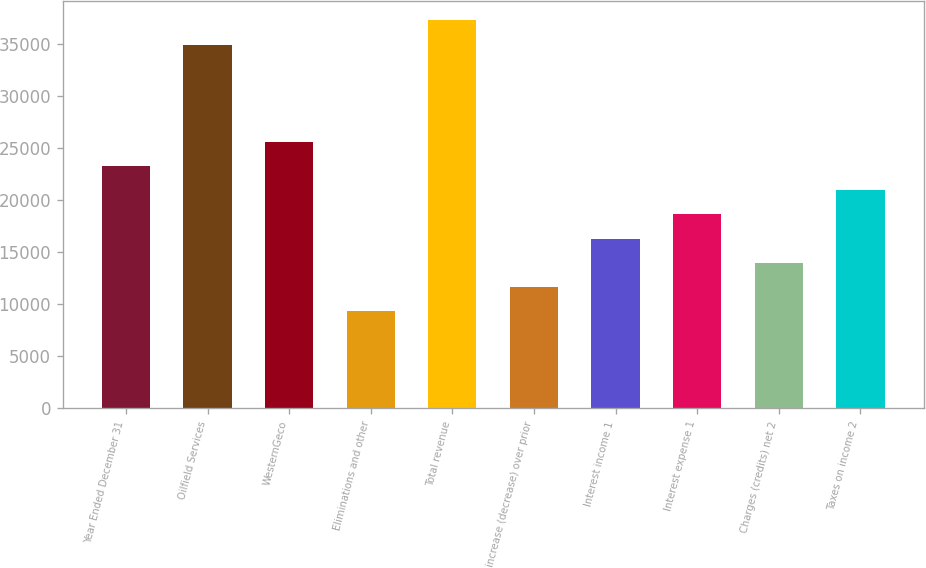Convert chart. <chart><loc_0><loc_0><loc_500><loc_500><bar_chart><fcel>Year Ended December 31<fcel>Oilfield Services<fcel>WesternGeco<fcel>Eliminations and other<fcel>Total revenue<fcel>increase (decrease) over prior<fcel>Interest income 1<fcel>Interest expense 1<fcel>Charges (credits) net 2<fcel>Taxes on income 2<nl><fcel>23277<fcel>34915.2<fcel>25604.6<fcel>9311.22<fcel>37242.8<fcel>11638.9<fcel>16294.1<fcel>18621.7<fcel>13966.5<fcel>20949.4<nl></chart> 